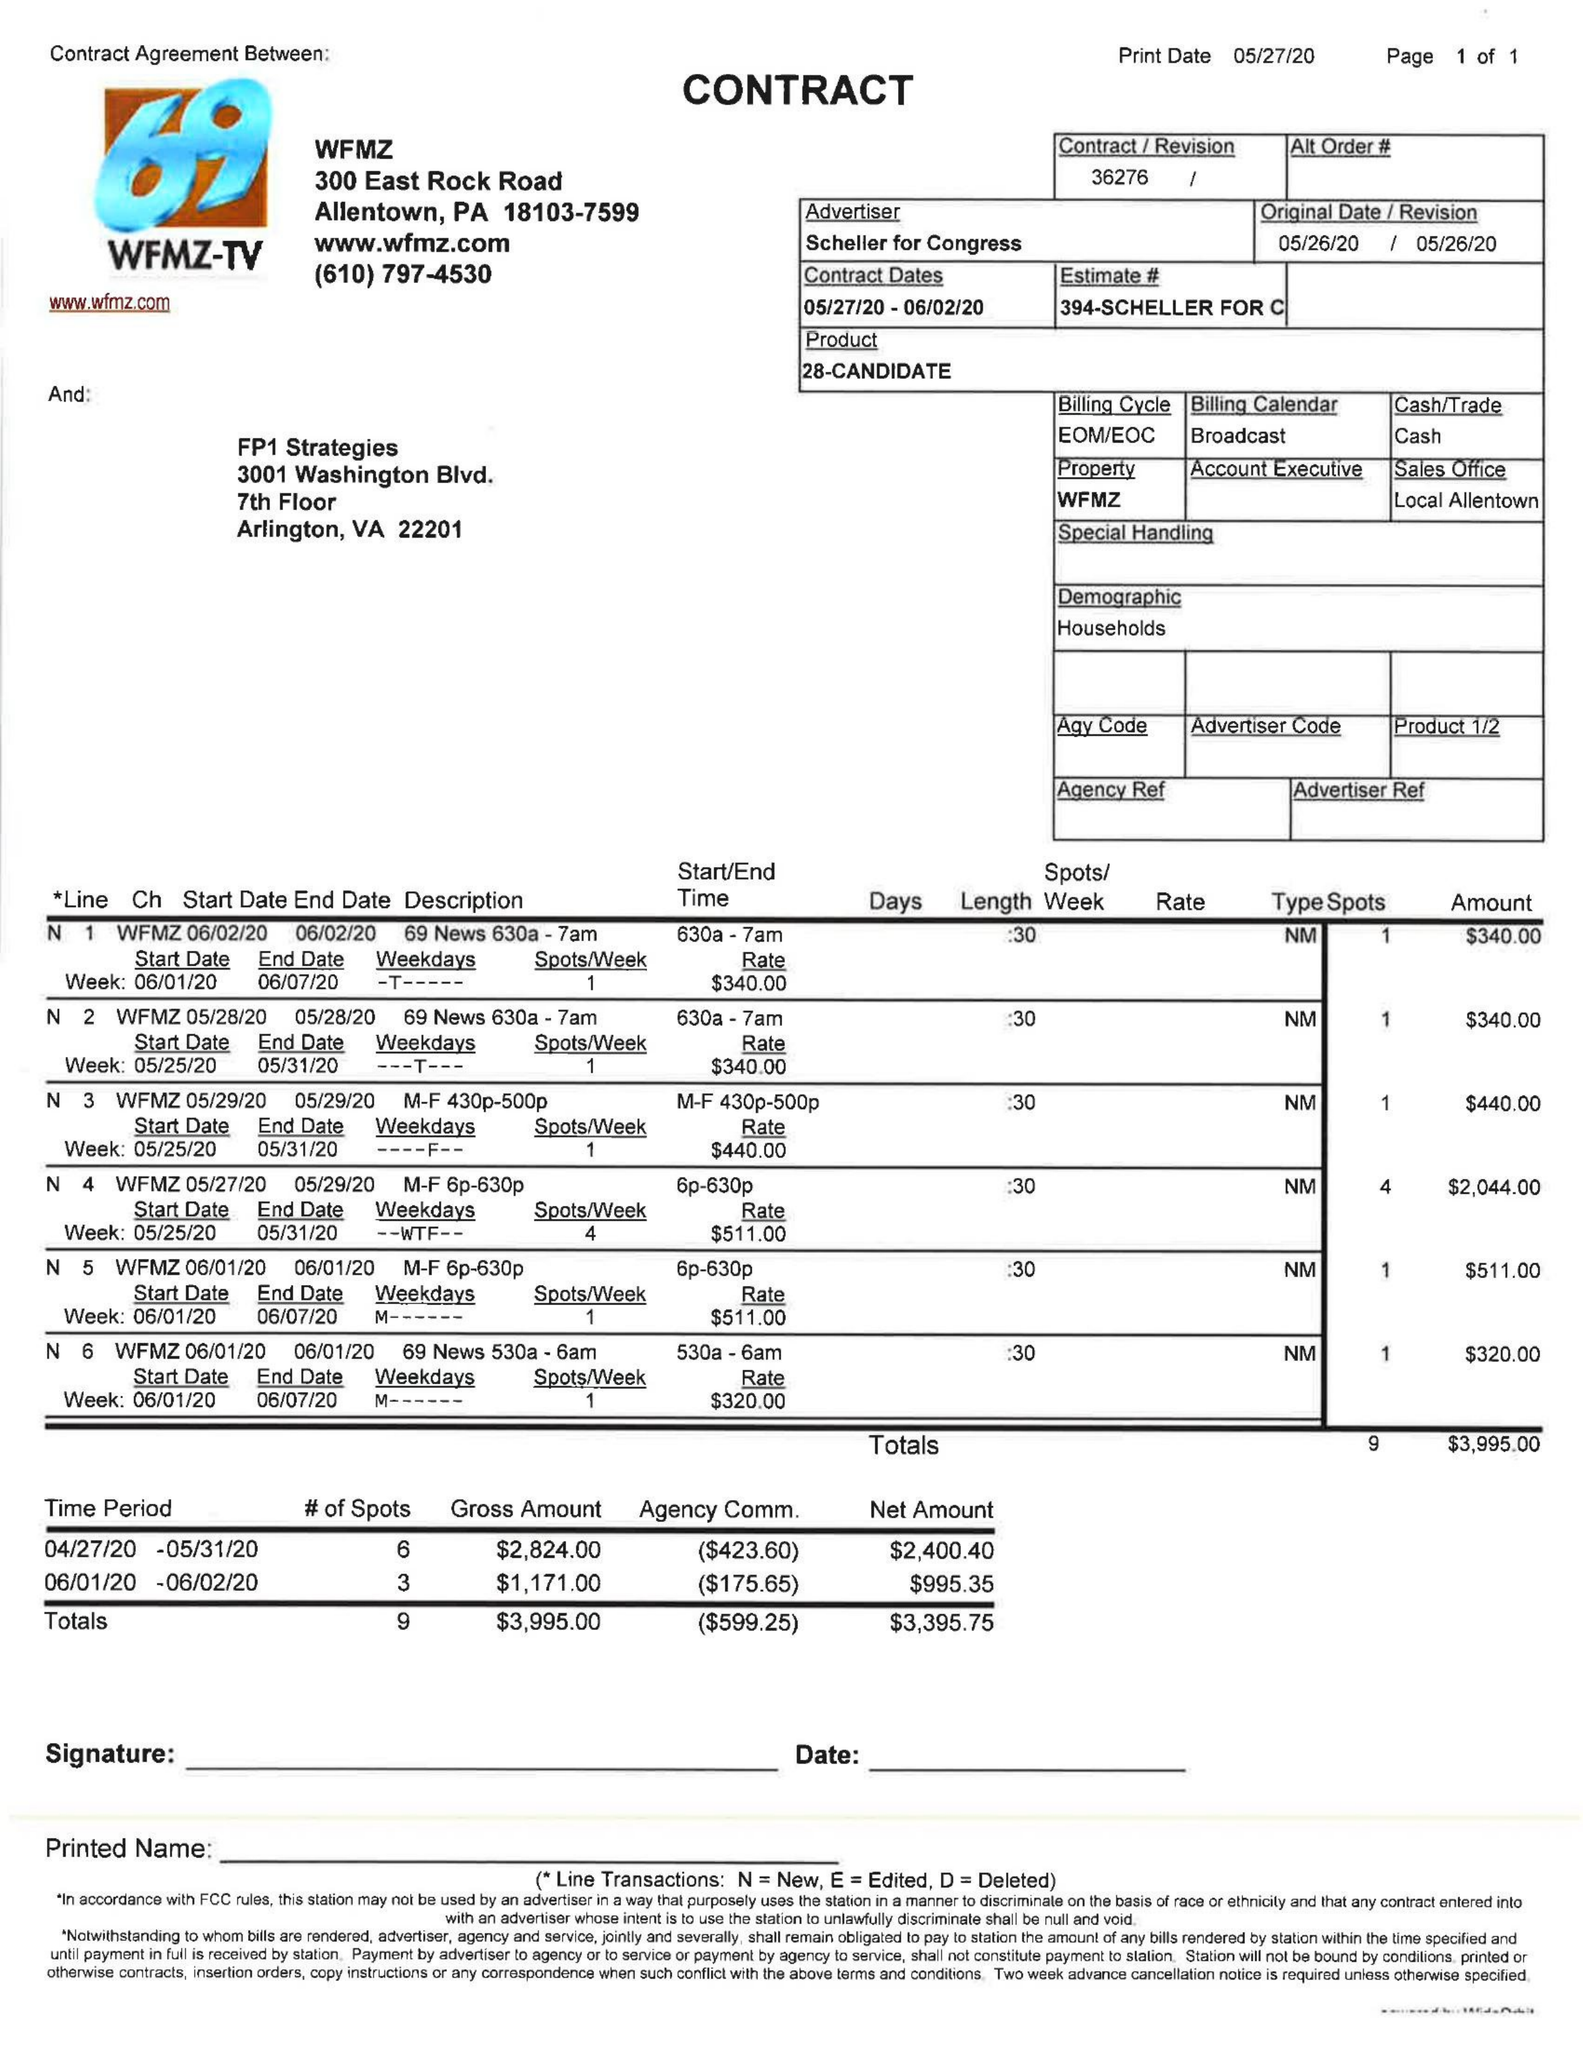What is the value for the gross_amount?
Answer the question using a single word or phrase. 3995.00 